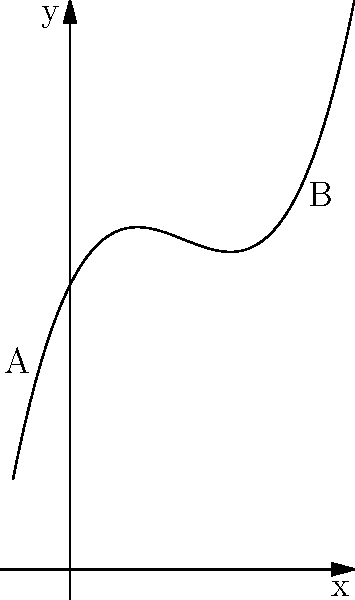The curve shown represents the swing path of your golf club during a drive at Marlborough Golf Club. The path is modeled by the function $f(x) = 0.05x^3 - 0.6x^2 + 2x + 10$, where $x$ represents the horizontal distance and $f(x)$ the vertical distance, both in feet. What is the maximum height of the club head during the swing? To find the maximum height of the club head, we need to follow these steps:

1) The maximum height occurs at the highest point of the curve, where the slope is zero.

2) The slope of the function is given by its derivative:
   $f'(x) = 0.15x^2 - 1.2x + 2$

3) Set the derivative to zero and solve for x:
   $0.15x^2 - 1.2x + 2 = 0$

4) This is a quadratic equation. We can solve it using the quadratic formula:
   $x = \frac{-b \pm \sqrt{b^2 - 4ac}}{2a}$

   Where $a = 0.15$, $b = -1.2$, and $c = 2$

5) Plugging in these values:
   $x = \frac{1.2 \pm \sqrt{1.44 - 1.2}}{0.3} = \frac{1.2 \pm \sqrt{0.24}}{0.3} = \frac{1.2 \pm 0.49}{0.3}$

6) This gives us two solutions:
   $x_1 = \frac{1.2 + 0.49}{0.3} \approx 5.63$ and $x_2 = \frac{1.2 - 0.49}{0.3} \approx 2.37$

7) The larger value, 5.63, corresponds to the maximum (the smaller value is a local minimum).

8) To find the maximum height, we plug this x-value back into our original function:
   $f(5.63) = 0.05(5.63)^3 - 0.6(5.63)^2 + 2(5.63) + 10 \approx 13.95$

Therefore, the maximum height of the club head during the swing is approximately 13.95 feet.
Answer: 13.95 feet 